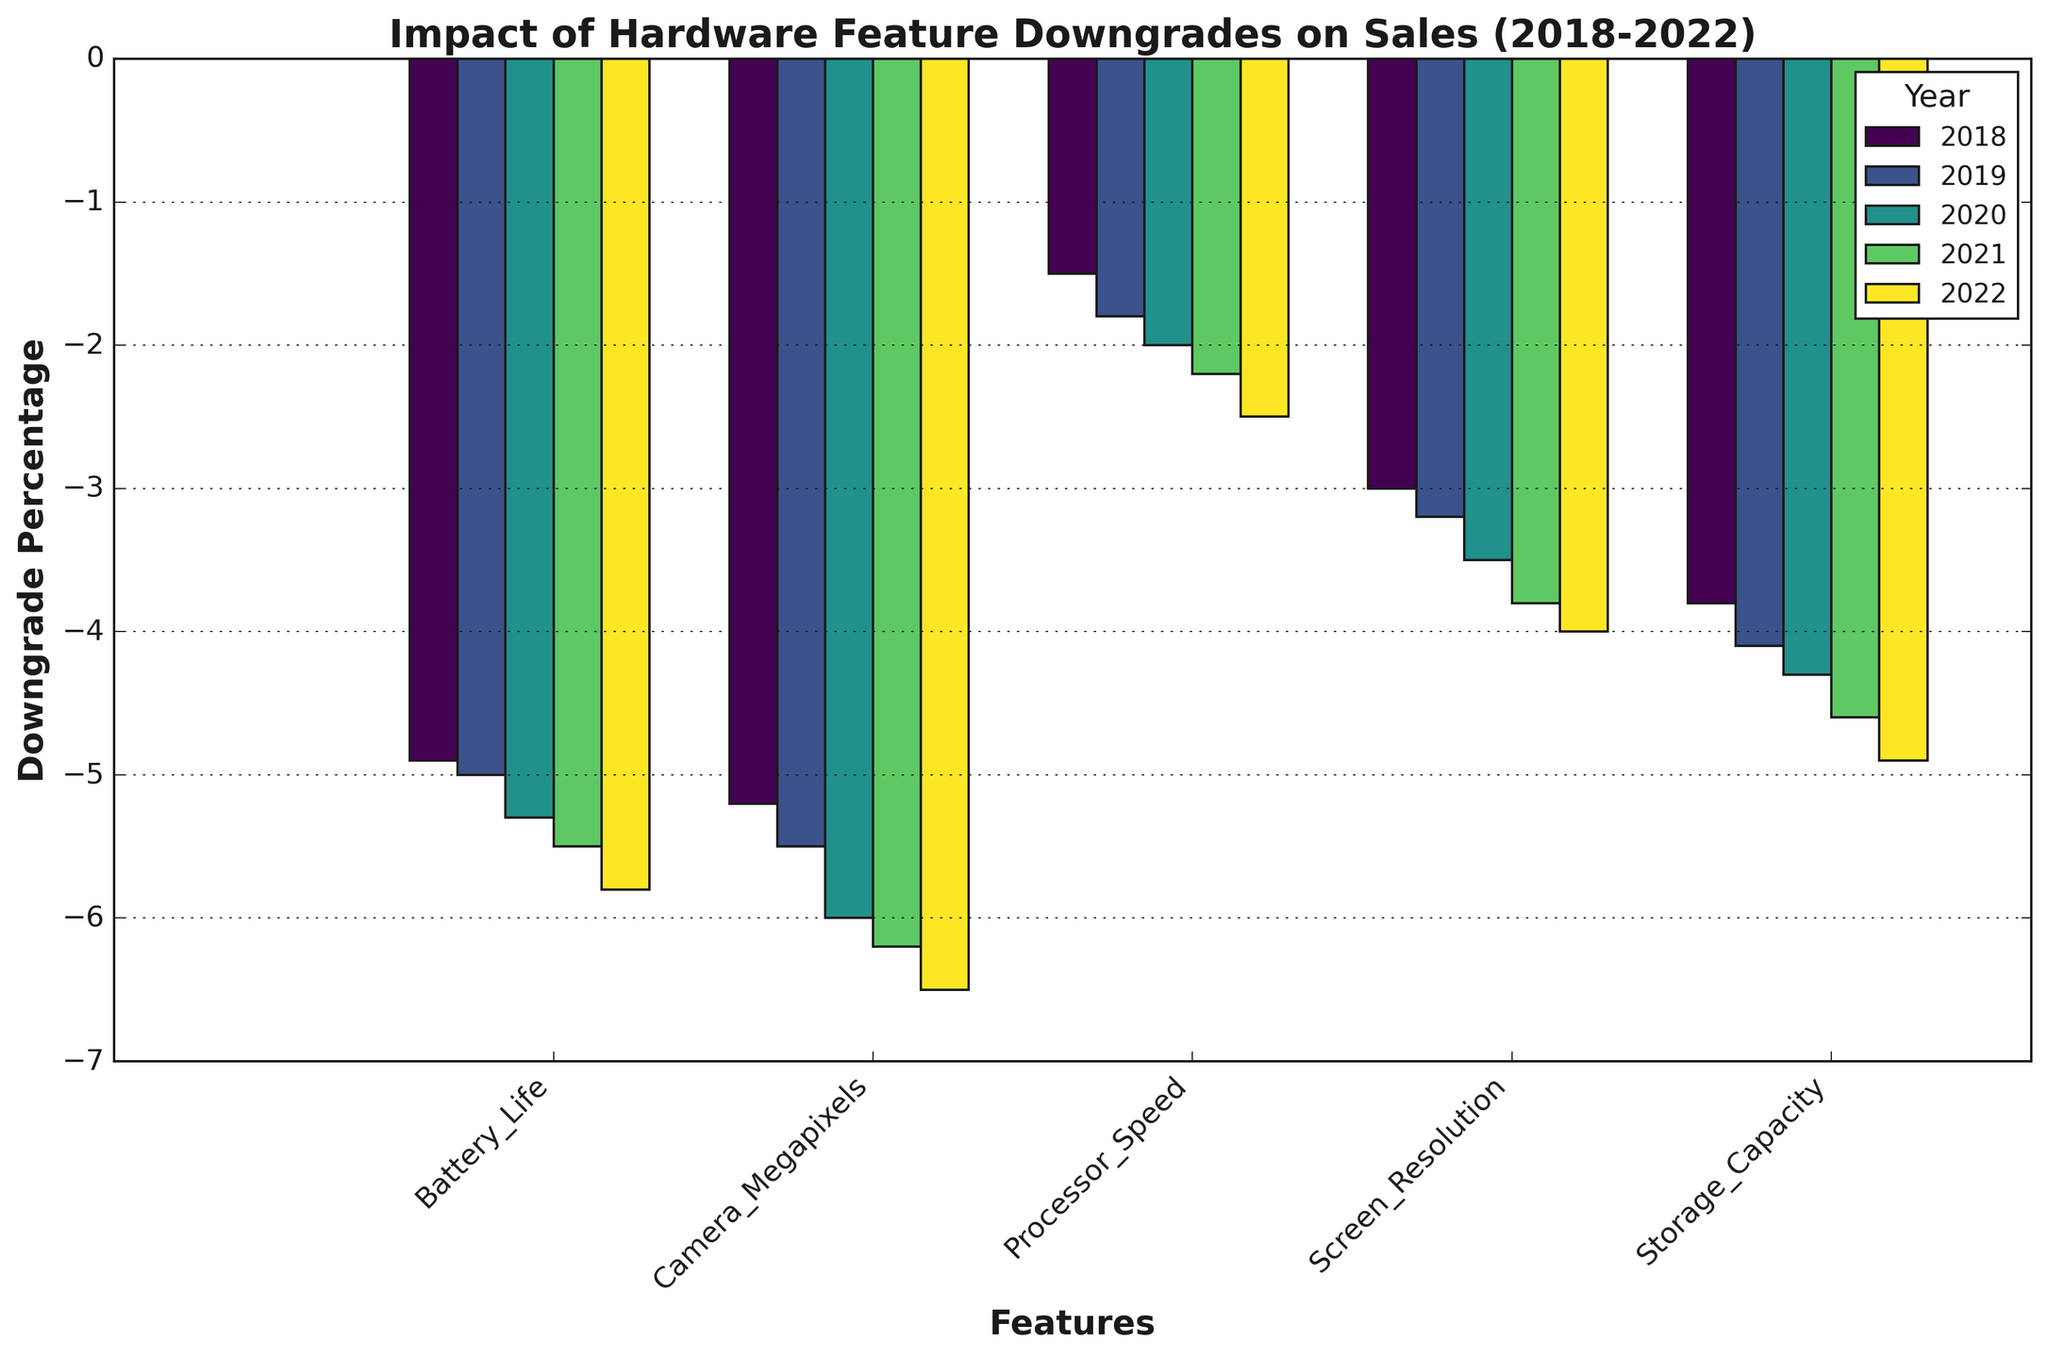How did the downgrade in Battery Life impact sales from 2018 to 2022 overall? To determine the overall impact, we need to observe the negative values for Battery Life for each year from 2018 to 2022. The values are -4.9%, -5.0%, -5.3%, -5.5%, and -5.8%. We can see a consistent increase in the negative percentage each year.
Answer: It worsened overall Which year's downgrade in Camera Megapixels had the highest negative impact on sales? By visually inspecting the chart, we can identify the bar representing the most negative value for Camera Megapixels. The largest negative impact is in 2022 with a -6.5% downgrade.
Answer: 2022 Compare the impact of downgrades in Storage Capacity and Processor Speed in 2021. Which had a greater negative impact? From the figure, locate the bars for Storage Capacity and Processor Speed in 2021. Storage Capacity shows -4.6%, and Processor Speed shows -2.2%. Storage Capacity has a greater negative impact.
Answer: Storage Capacity What is the total downgrade percentage across all features in 2020? Examine the bar heights for all features in 2020 and sum up the values: -6.0% (Camera Megapixels) + -5.3% (Battery Life) + -4.3% (Storage Capacity) + -3.5% (Screen Resolution) + -2.0% (Processor Speed). The total is -21.1%.
Answer: -21.1% Which feature showed the least negative impact across all years? By visually comparing the heights of all bars for all years, we can see that Processor Speed consistently has the least negative impact with values never lower than -2.5%.
Answer: Processor Speed In which year did the feature Screen Resolution see its highest negative impact on sales? Look at the heights of the bars for Screen Resolution across all years. The highest value is in 2022 with a -4.0% downgrade.
Answer: 2022 What is the average downgrade percentage for Camera Megapixels from 2018 to 2022? Calculate the average of the values for Camera Megapixels over the years: (-5.2 + -5.5 + -6.0 + -6.2 + -6.5) / 5. The sum is -29.4, and the average is -29.4 / 5 = -5.88.
Answer: -5.88 Which year had the least overall negative impact on sales due to hardware feature downgrades? By summing up the negative percentages for each year: 2018 (-18.4%), 2019 (-19.6%), 2020 (-21.1%), 2021 (-22.3%), 2022 (-23.7%). The least is in 2018 with a total of -18.4%.
Answer: 2018 Compare the impact of downgrades in Battery Life in 2018 and Processor Speed in 2022. Which had a greater negative impact? Locate the values for Battery Life in 2018 (-4.9%) and Processor Speed in 2022 (-2.5%). Battery Life in 2018 had a greater negative impact.
Answer: Battery Life in 2018 Which year's downgrades had the highest overall negative impact on sales? Sum up the negative percentages for each year and compare: 2018 (-18.4%), 2019 (-19.6%), 2020 (-21.1%), 2021 (-22.3%), 2022 (-23.7%). The highest is in 2022 with -23.7%.
Answer: 2022 